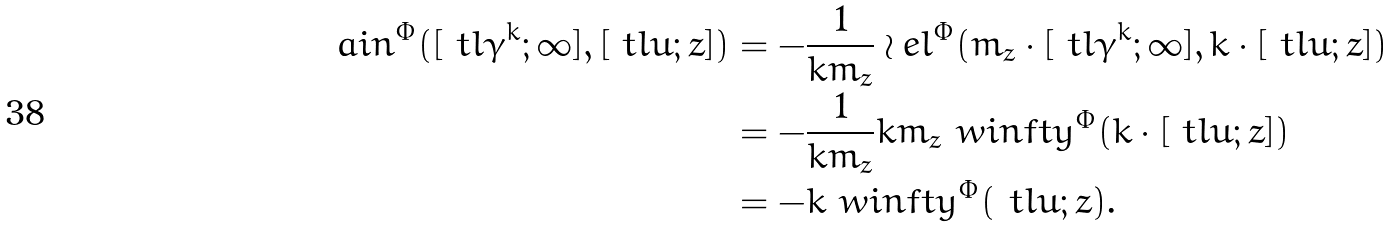Convert formula to latex. <formula><loc_0><loc_0><loc_500><loc_500>\ a i n ^ { \Phi } ( [ \ t l \gamma ^ { k } ; \infty ] , [ \ t l u ; z ] ) & = - \frac { 1 } { k m _ { z } } \wr e l ^ { \Phi } ( m _ { z } \cdot [ \ t l \gamma ^ { k } ; \infty ] , k \cdot [ \ t l u ; z ] ) \\ & = - \frac { 1 } { k m _ { z } } k m _ { z } \ w i n f t y ^ { \Phi } ( k \cdot [ \ t l u ; z ] ) \\ & = - k \ w i n f t y ^ { \Phi } ( \ t l u ; z ) .</formula> 